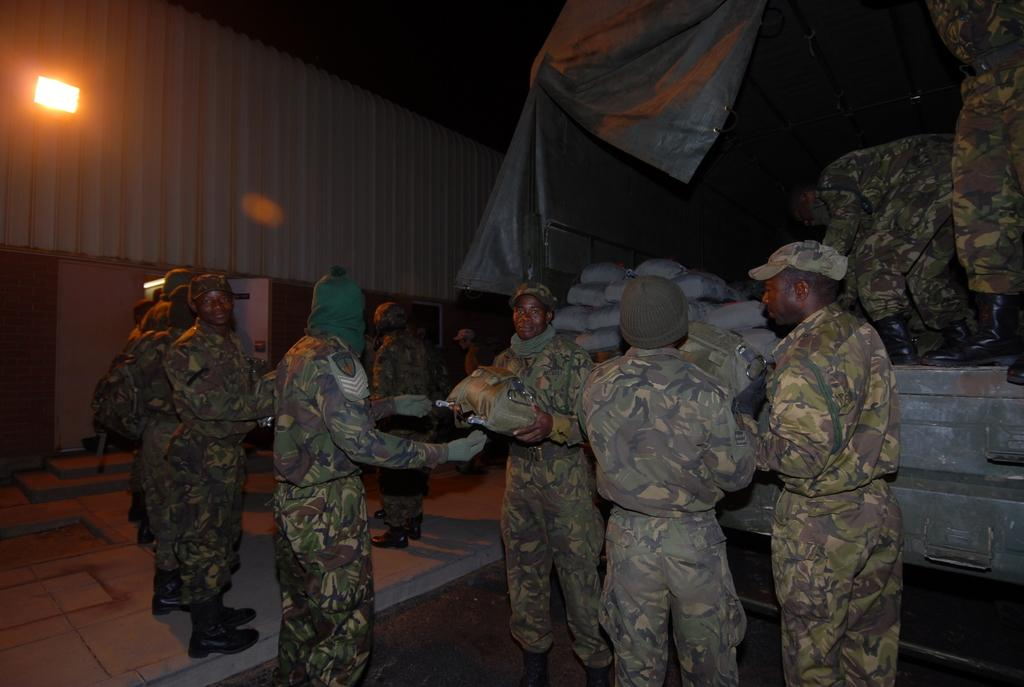What is on the right side of the image? There is a vehicle with sacks on the right side of the image. What are the people on the vehicle doing? Some people are standing on the vehicle. What can be seen in the image besides the vehicle and people? There are many soldiers in the image. What are the soldiers wearing on their heads? The soldiers are wearing caps. What is visible in the background of the image? There is a building with a light in the background of the image. What type of juice is being served to the soldiers in the image? There is no juice present in the image; the soldiers are not shown consuming any beverages. What emotion are the soldiers expressing in the image? The image does not convey any specific emotions, such as surprise or hate, as it only shows the soldiers' appearance and actions. 